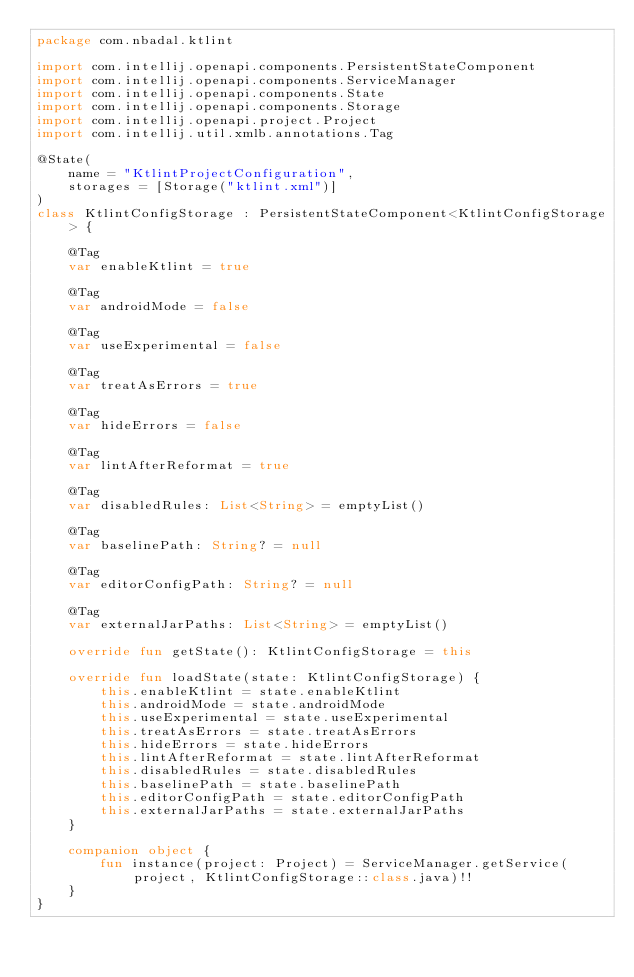Convert code to text. <code><loc_0><loc_0><loc_500><loc_500><_Kotlin_>package com.nbadal.ktlint

import com.intellij.openapi.components.PersistentStateComponent
import com.intellij.openapi.components.ServiceManager
import com.intellij.openapi.components.State
import com.intellij.openapi.components.Storage
import com.intellij.openapi.project.Project
import com.intellij.util.xmlb.annotations.Tag

@State(
    name = "KtlintProjectConfiguration",
    storages = [Storage("ktlint.xml")]
)
class KtlintConfigStorage : PersistentStateComponent<KtlintConfigStorage> {

    @Tag
    var enableKtlint = true

    @Tag
    var androidMode = false

    @Tag
    var useExperimental = false

    @Tag
    var treatAsErrors = true

    @Tag
    var hideErrors = false

    @Tag
    var lintAfterReformat = true

    @Tag
    var disabledRules: List<String> = emptyList()

    @Tag
    var baselinePath: String? = null

    @Tag
    var editorConfigPath: String? = null

    @Tag
    var externalJarPaths: List<String> = emptyList()

    override fun getState(): KtlintConfigStorage = this

    override fun loadState(state: KtlintConfigStorage) {
        this.enableKtlint = state.enableKtlint
        this.androidMode = state.androidMode
        this.useExperimental = state.useExperimental
        this.treatAsErrors = state.treatAsErrors
        this.hideErrors = state.hideErrors
        this.lintAfterReformat = state.lintAfterReformat
        this.disabledRules = state.disabledRules
        this.baselinePath = state.baselinePath
        this.editorConfigPath = state.editorConfigPath
        this.externalJarPaths = state.externalJarPaths
    }

    companion object {
        fun instance(project: Project) = ServiceManager.getService(project, KtlintConfigStorage::class.java)!!
    }
}
</code> 